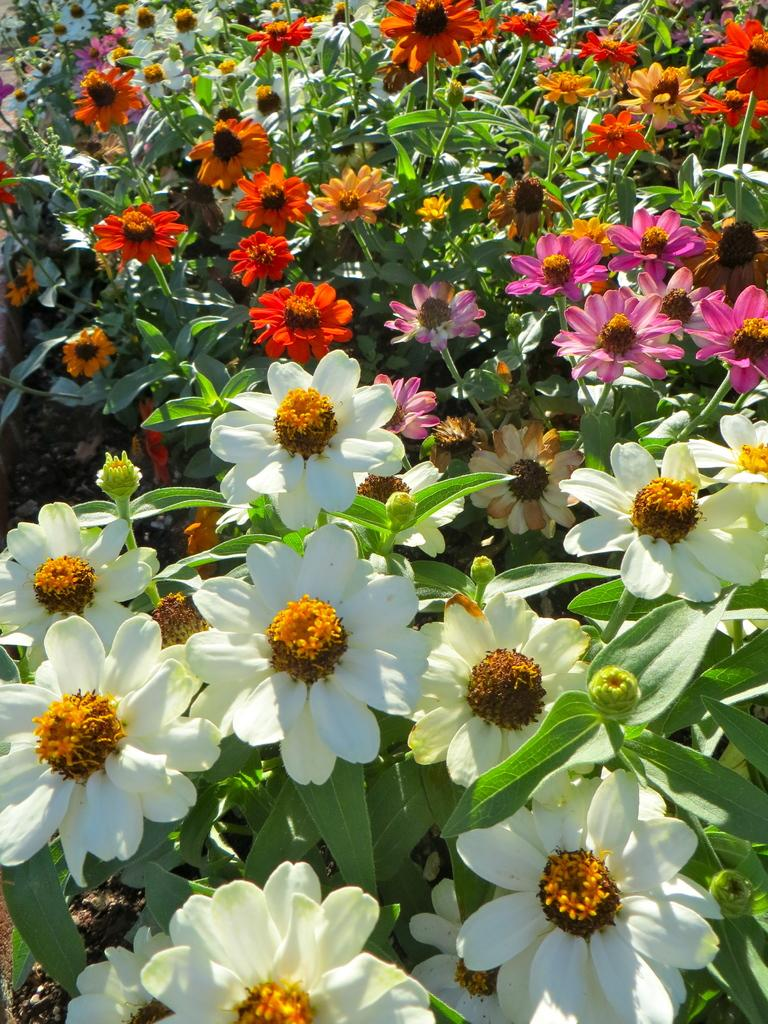What type of living organisms can be seen in the image? There are colorful flowers in the image. Can you describe the stage of growth for some of the flowers? Yes, there are buds in the image. What else is present in the image besides flowers? There are plants in the image. What type of rock can be seen supporting the flowers in the image? There is no rock present in the image; it features colorful flowers and plants. How does the bulb affect the growth of the flowers in the image? There is no mention of a bulb in the image, so it cannot be determined how it might affect the growth of the flowers. 